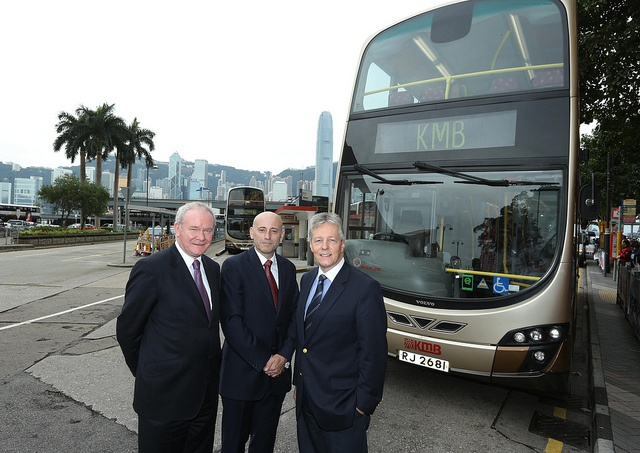Describe the objects in this image and their specific colors. I can see bus in white, black, gray, and darkgray tones, people in white, black, lightpink, darkgray, and gray tones, people in white, black, tan, gray, and darkgray tones, people in white, black, gray, and darkgray tones, and bus in white, black, gray, darkgray, and darkgreen tones in this image. 